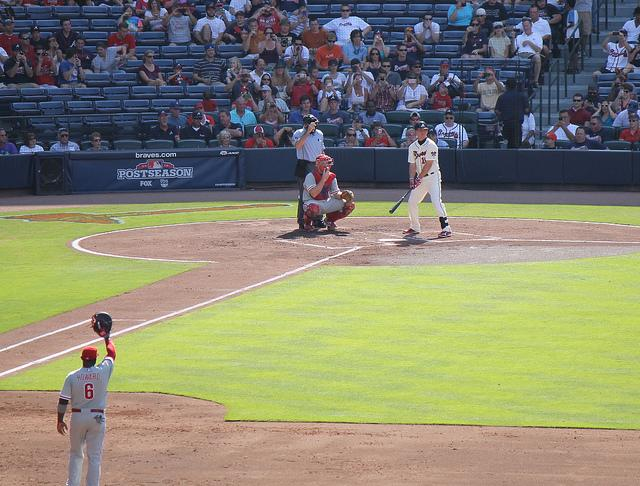What switch hitting Atlanta Braves legend is at the plate?

Choices:
A) ozzie albies
B) chipper jones
C) freddie freeman
D) otis nixon chipper jones 